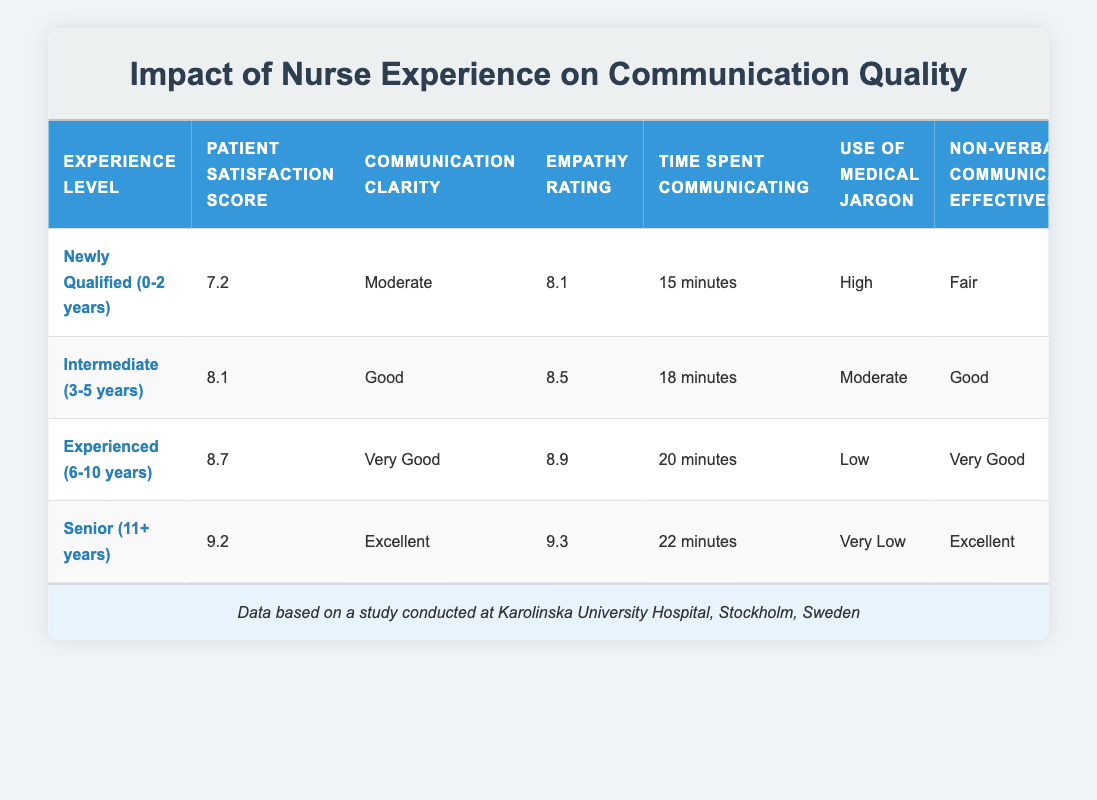What is the Patient Satisfaction Score for Experienced nurses (6-10 years)? The Patient Satisfaction Score for Experienced nurses is directly mentioned in the table. It is 8.7.
Answer: 8.7 What is the Communication Clarity for Senior nurses (11+ years)? The Communication Clarity for Senior nurses is explicitly stated in the table as "Excellent."
Answer: Excellent How much time do Newly Qualified nurses spend communicating compared to Intermediate nurses? Newly Qualified nurses spend 15 minutes communicating, while Intermediate nurses spend 18 minutes. The difference is 18 - 15 = 3 minutes.
Answer: 3 minutes Is the use of Medical Jargon lower for Experienced nurses compared to Newly Qualified nurses? The table shows that Experienced nurses have a "Low" usage of Medical Jargon, while Newly Qualified nurses have a "High" usage. Therefore, it is true that Experienced nurses use less Medical Jargon.
Answer: Yes What is the average Patient Satisfaction Score among all experience levels? To find the average, sum the scores: 7.2 + 8.1 + 8.7 + 9.2 = 33.2. There are 4 experience levels, so the average is 33.2 / 4 = 8.3.
Answer: 8.3 How many minutes do Senior nurses spend communicating more than Newly Qualified nurses? Senior nurses spend 22 minutes, and Newly Qualified nurses spend 15 minutes. The difference is 22 - 15 = 7 minutes.
Answer: 7 minutes Do nurses with more experience generally have higher Empathy Ratings? The Empathy Ratings increase with experience: 8.1 (Newly Qualified), 8.5 (Intermediate), 8.9 (Experienced), and 9.3 (Senior). Thus, it confirms that higher experience is associated with higher Empathy Ratings.
Answer: Yes How does the Non-verbal Communication Effectiveness differ from Newly Qualified to Senior nurses? For Newly Qualified nurses, Non-verbal Communication Effectiveness is rated as "Fair," while for Senior nurses, it is rated as "Excellent." This indicates a clear improvement in effectiveness with experience.
Answer: It improves from Fair to Excellent 